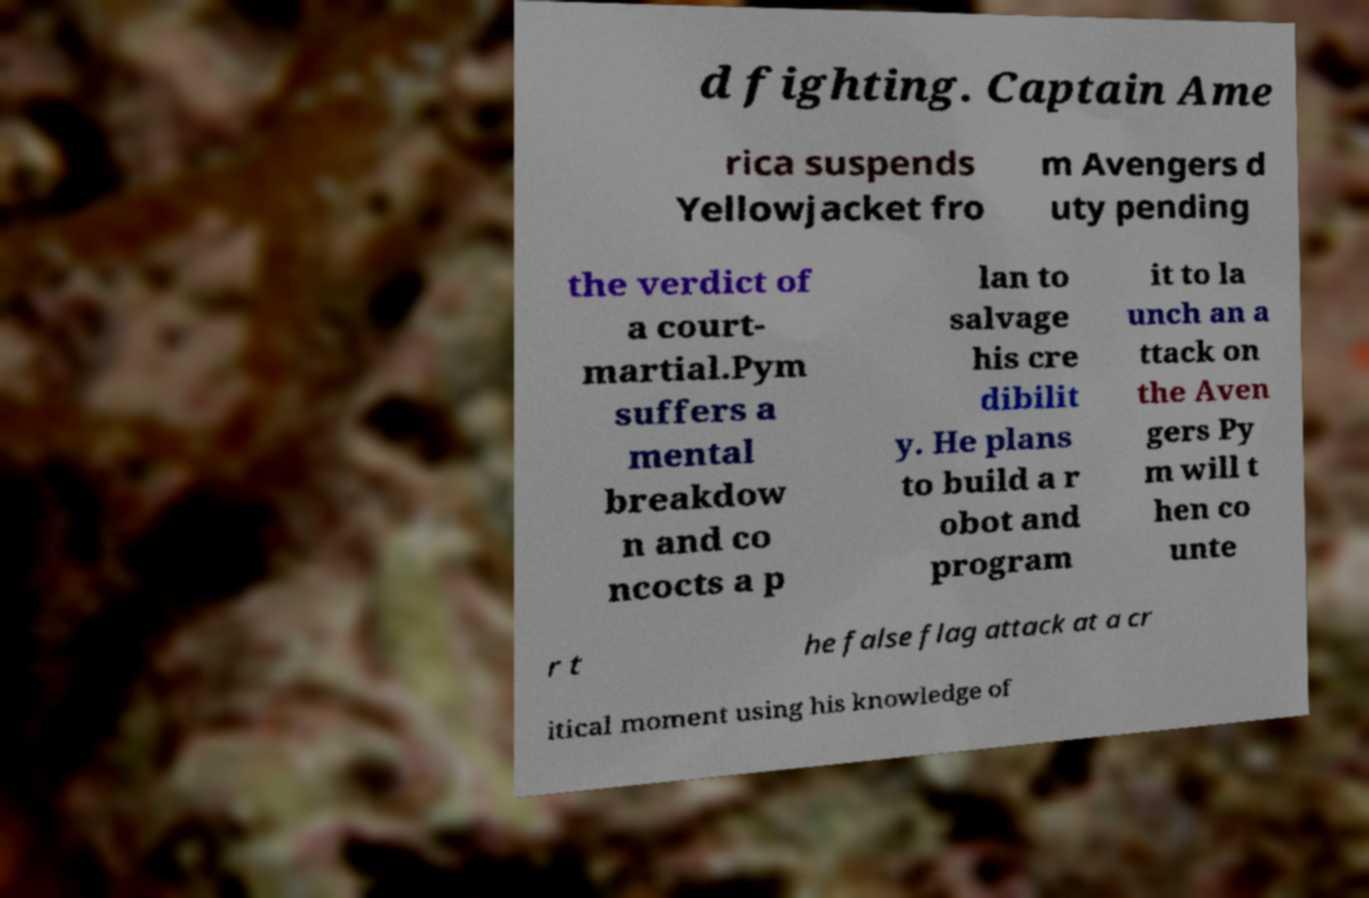Could you assist in decoding the text presented in this image and type it out clearly? d fighting. Captain Ame rica suspends Yellowjacket fro m Avengers d uty pending the verdict of a court- martial.Pym suffers a mental breakdow n and co ncocts a p lan to salvage his cre dibilit y. He plans to build a r obot and program it to la unch an a ttack on the Aven gers Py m will t hen co unte r t he false flag attack at a cr itical moment using his knowledge of 